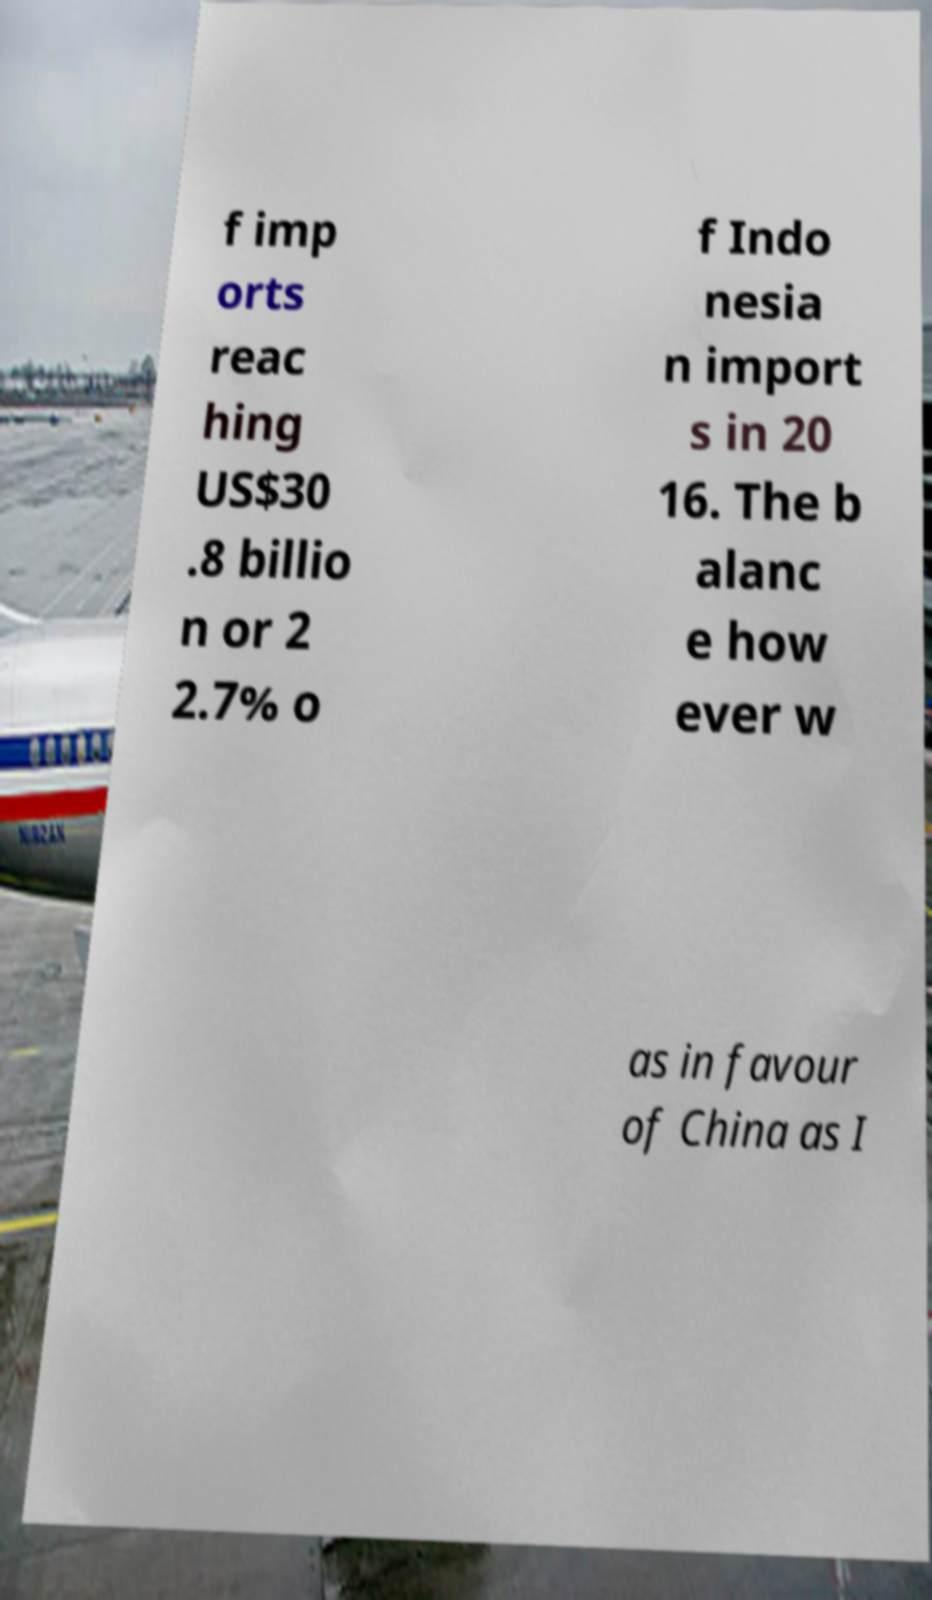Please read and relay the text visible in this image. What does it say? f imp orts reac hing US$30 .8 billio n or 2 2.7% o f Indo nesia n import s in 20 16. The b alanc e how ever w as in favour of China as I 